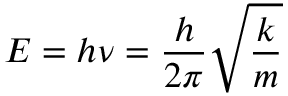Convert formula to latex. <formula><loc_0><loc_0><loc_500><loc_500>E = h \nu = { \frac { h } { 2 \pi } } { \sqrt { \frac { k } { m } } }</formula> 